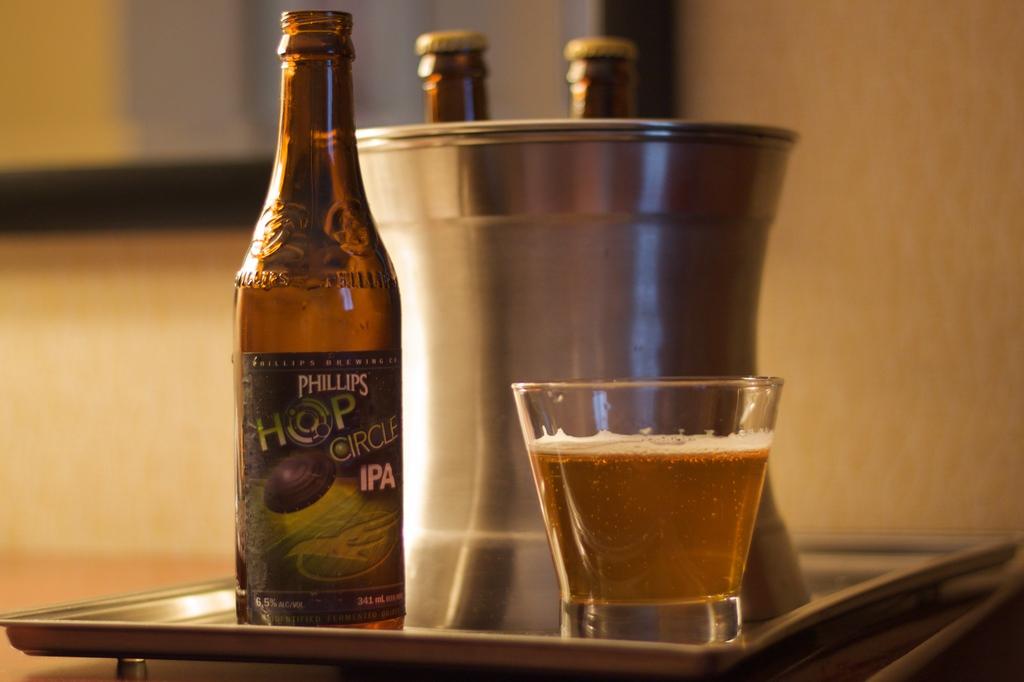What kind of beer is this?
Ensure brevity in your answer.  Phillips hop circle ipa. 